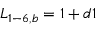Convert formula to latex. <formula><loc_0><loc_0><loc_500><loc_500>{ L _ { 1 - 6 , b } } = 1 + d 1</formula> 